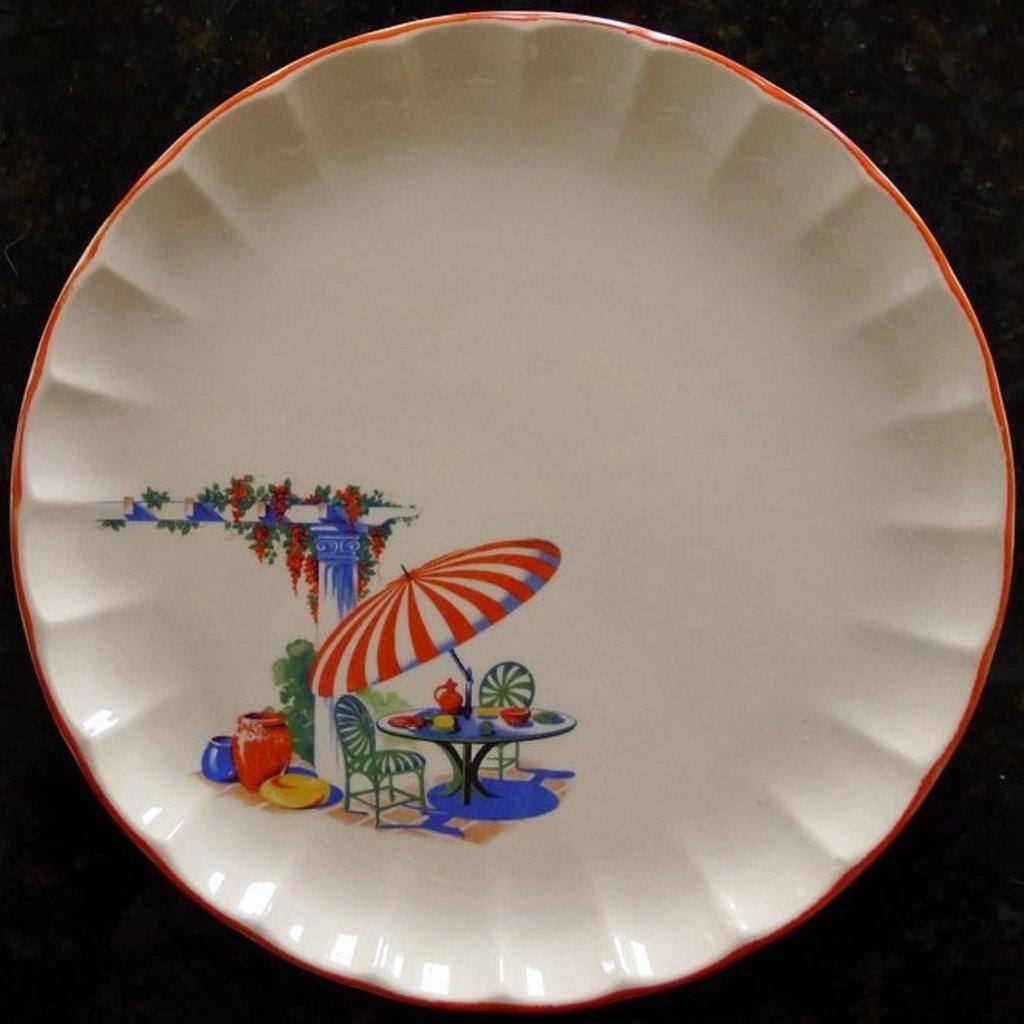What is on the plate in the image? There is a painting on the plate in the image. What is the subject of the painting? The painting depicts a table, chairs, an umbrella, plants, and pots. What is the color of the background in the image? The background of the image is dark. Can you see any beetles crawling on the ground in the image? There is no ground or beetles present in the image; it features a plate with a painting. What type of plane is flying in the background of the image? There is no plane present in the image; it features a plate with a painting. 